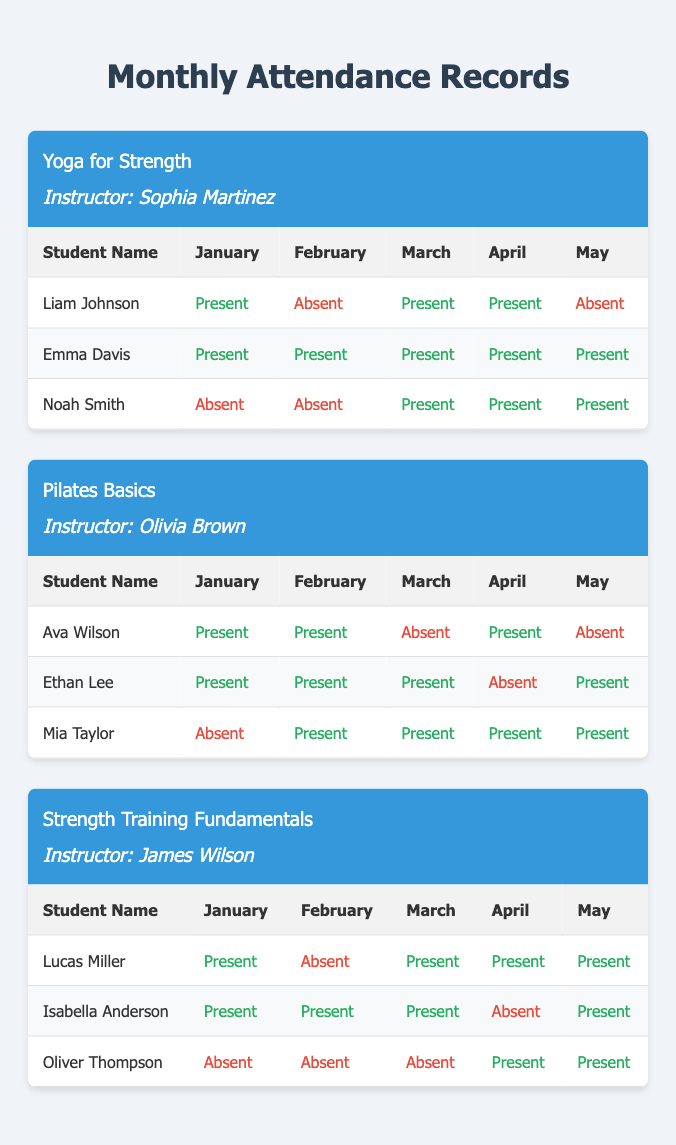What is the attendance status of Liam Johnson in March? Liam Johnson is present in March according to the attendance data for the Yoga for Strength class.
Answer: Present How many months was Emma Davis absent? Emma Davis was not absent at all; she was present for all five months: January, February, March, April, and May.
Answer: 0 Which student had the highest attendance in the Pilates Basics class? Ethan Lee had the highest attendance; using his records, he was absent only once in April, making his attendance count 4 out of 5 months (80%).
Answer: Ethan Lee What is the total number of absences for Noah Smith? For Noah Smith, he was absent in January (1), February (2), and, by counting attendances in March (1), April (1), and May (0), he was present 3 times. Adding all absences gives a total of 2.
Answer: 2 Did any student attend all classes in the Strength Training Fundamentals? Yes, both Lucas Miller and Isabella Anderson attended all but one class; Lucas missed February, while Isabella missed April, so no student attended all classes.
Answer: No Which class had the most students with perfect attendance? The Yoga for Strength class had the most perfect attendance students; Emma Davis was the only student with perfect attendance (5 presents), while others had at least one absent.
Answer: Yoga for Strength For the Pilates Basics class, what is the percentage of attended classes for Mia Taylor? Mia Taylor attended 4 out of 5 classes, which means her attendance percentage is (4/5) * 100 = 80%.
Answer: 80% How many students in the Strength Training Fundamentals class were present in both March and April? Lucas Miller and Oliver Thompson attended both March and April, so there are 2 students who were present in both months.
Answer: 2 What is the average attendance for the class Yoga for Strength? Emma Davis attended all classes (5), Liam Johnson attended 3 out of 5, and Noah Smith attended 3 out of 5, summing up their attendances gives us (5 + 3 + 3) = 11. The average attendance is 11/3 = 3.67 occasions per student in the class.
Answer: 3.67 